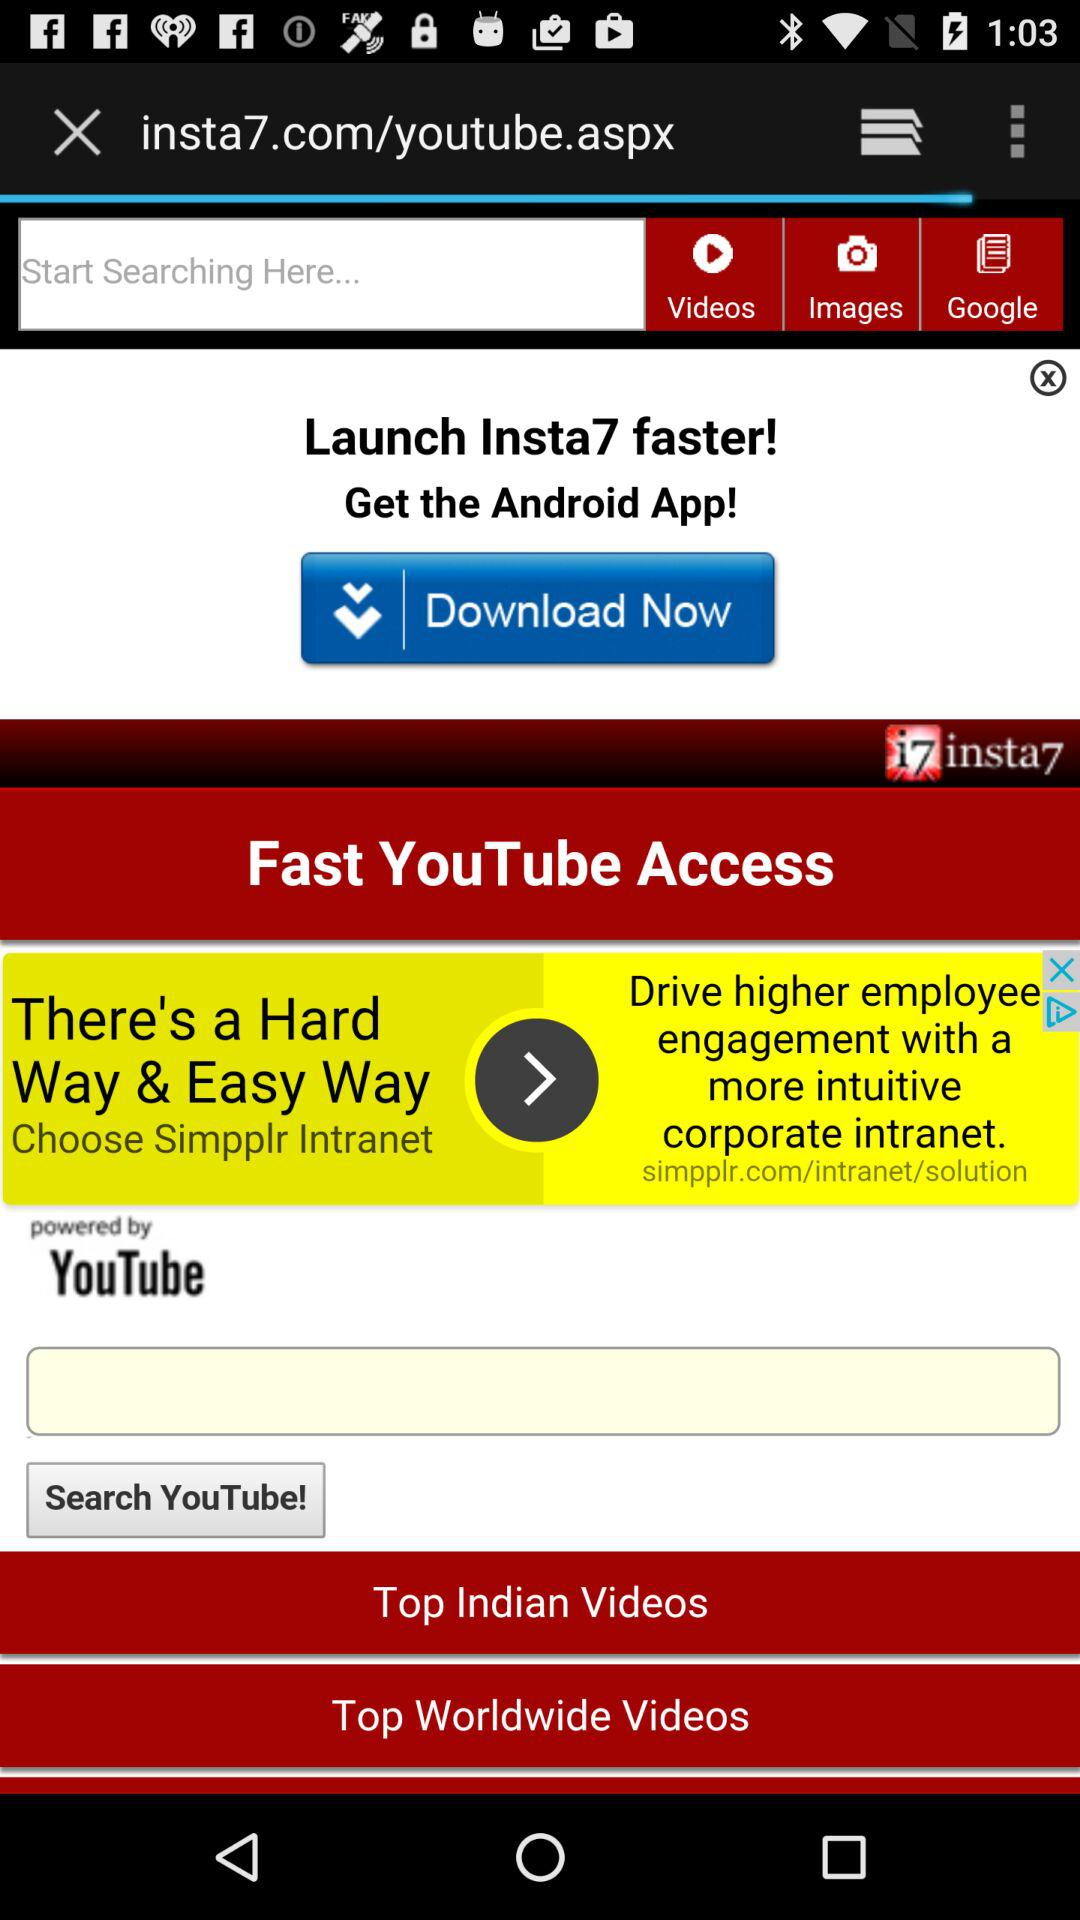Which application page is opening up?
When the provided information is insufficient, respond with <no answer>. <no answer> 